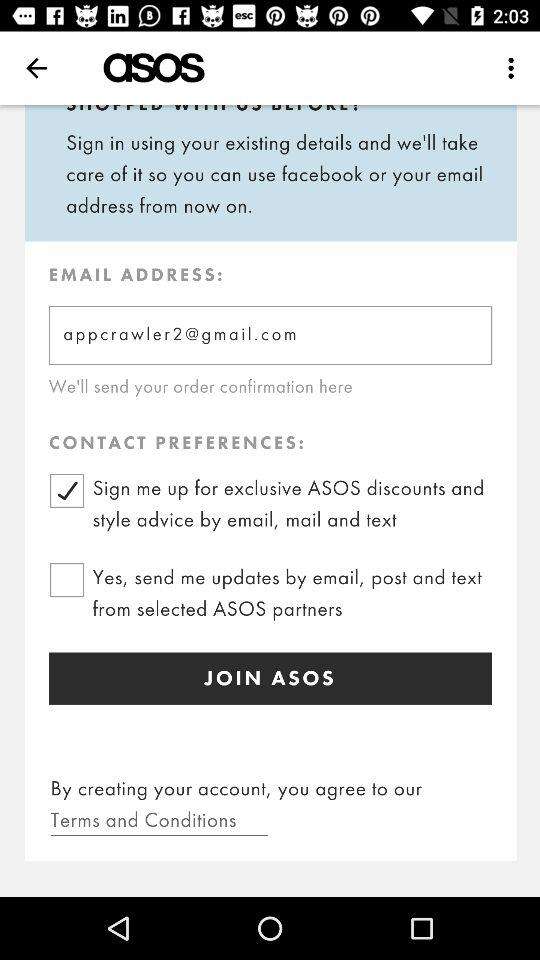What is the email address? The email address is appcrawler2@gmail.com. 